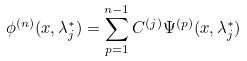Convert formula to latex. <formula><loc_0><loc_0><loc_500><loc_500>\phi ^ { ( n ) } ( x , \lambda _ { j } ^ { * } ) = \sum _ { p = 1 } ^ { n - 1 } C ^ { ( j ) } \Psi ^ { ( p ) } ( x , \lambda _ { j } ^ { * } )</formula> 